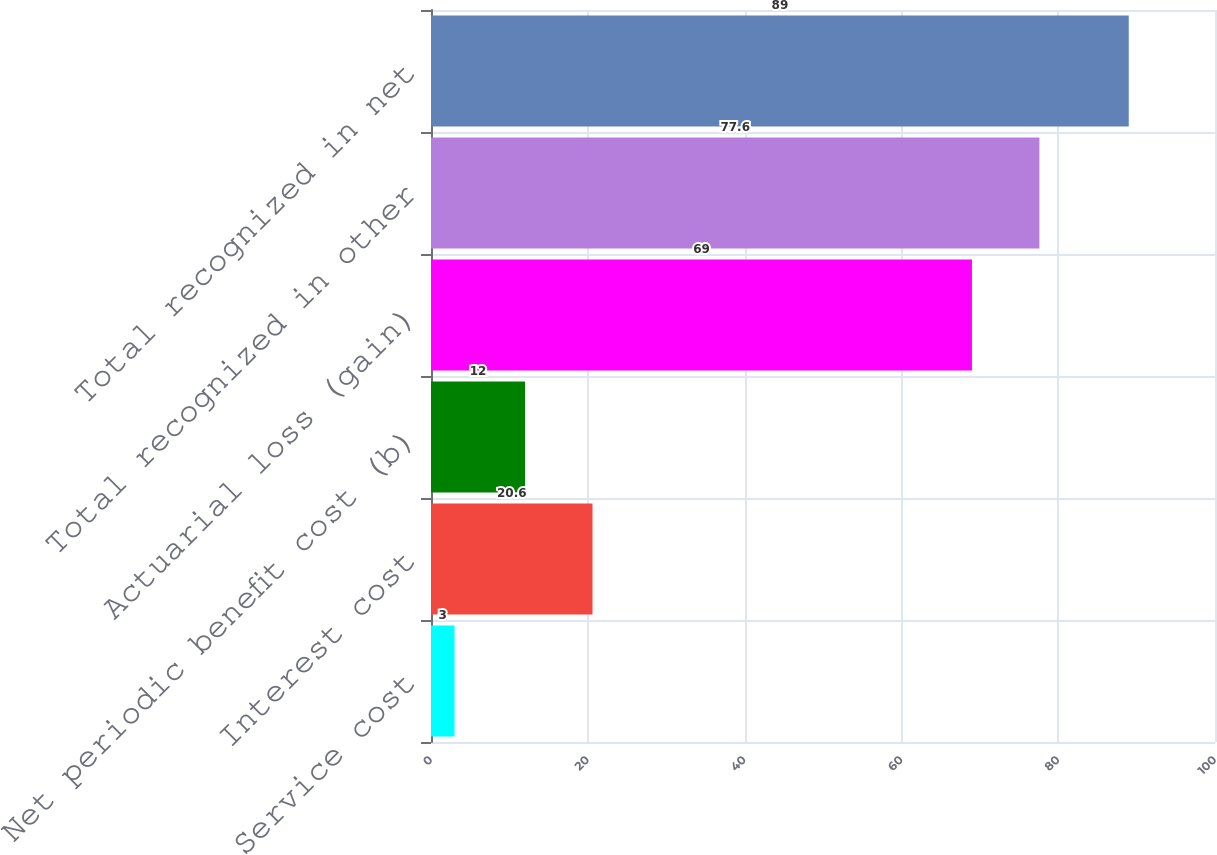Convert chart. <chart><loc_0><loc_0><loc_500><loc_500><bar_chart><fcel>Service cost<fcel>Interest cost<fcel>Net periodic benefit cost (b)<fcel>Actuarial loss (gain)<fcel>Total recognized in other<fcel>Total recognized in net<nl><fcel>3<fcel>20.6<fcel>12<fcel>69<fcel>77.6<fcel>89<nl></chart> 